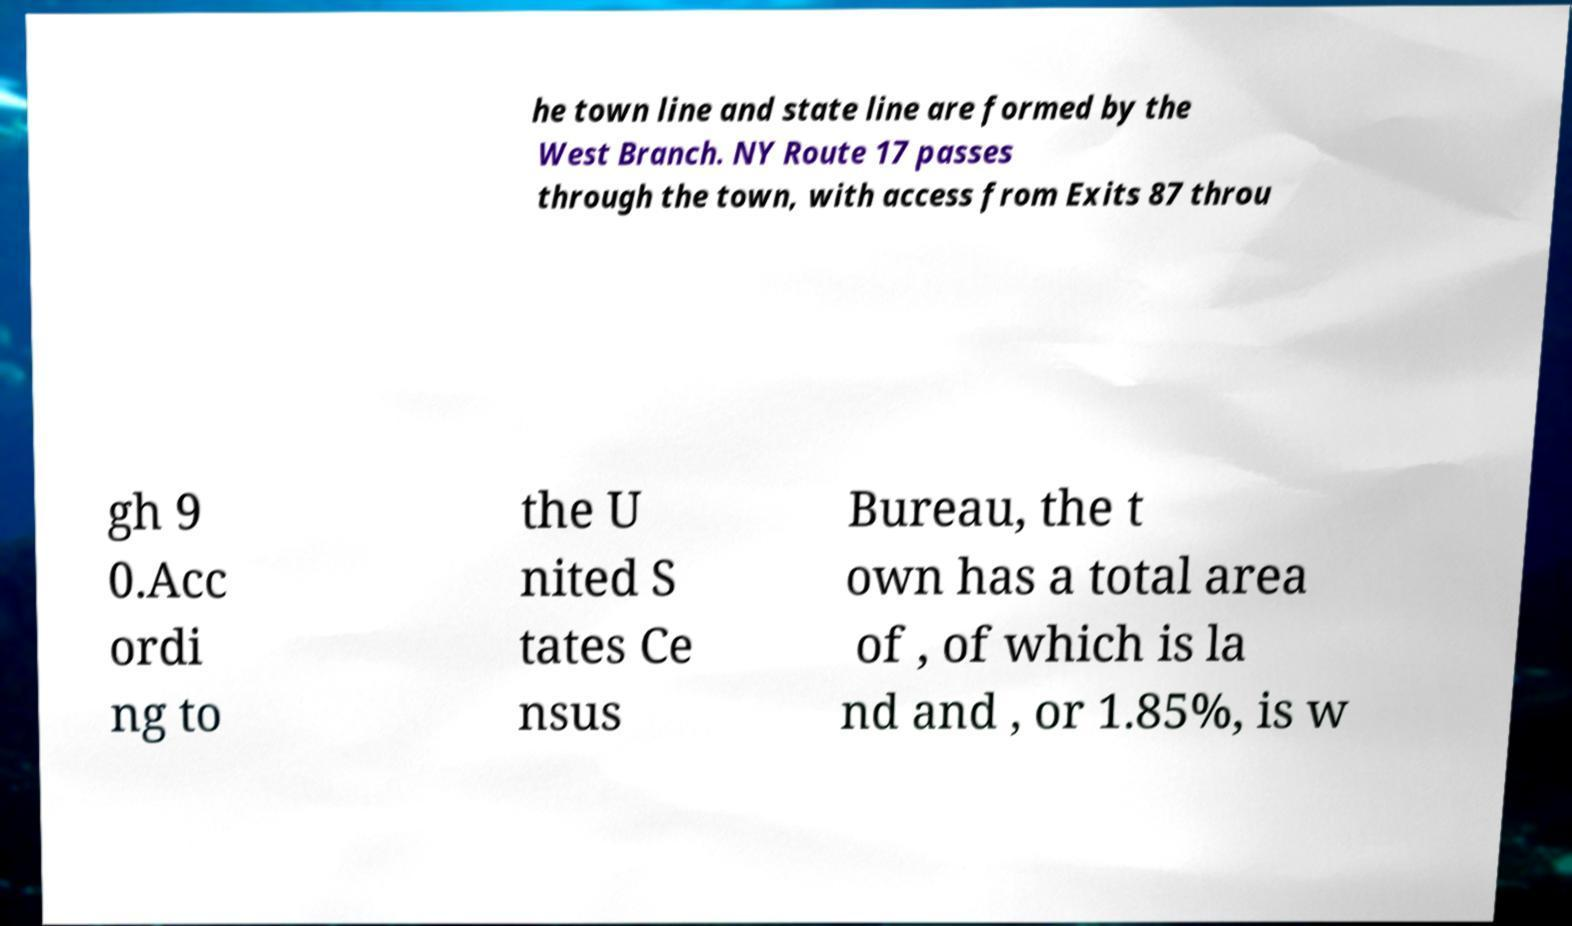Please identify and transcribe the text found in this image. he town line and state line are formed by the West Branch. NY Route 17 passes through the town, with access from Exits 87 throu gh 9 0.Acc ordi ng to the U nited S tates Ce nsus Bureau, the t own has a total area of , of which is la nd and , or 1.85%, is w 